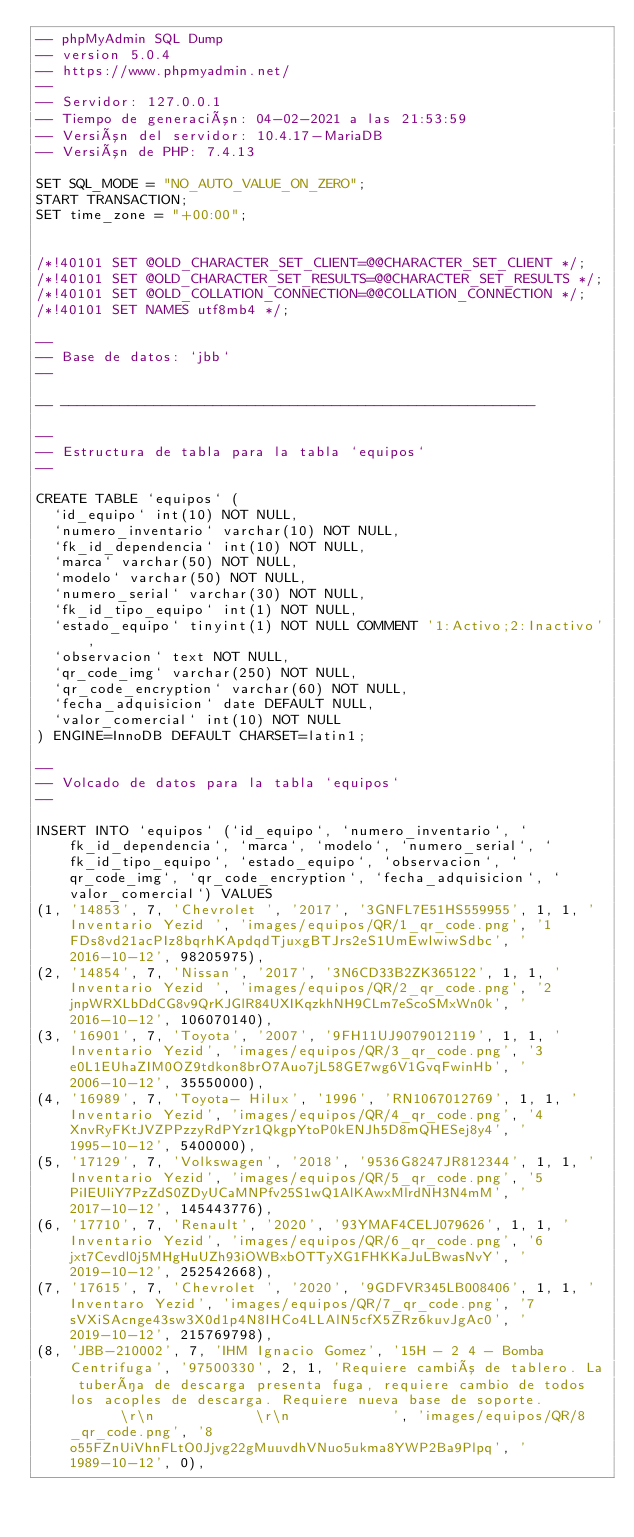<code> <loc_0><loc_0><loc_500><loc_500><_SQL_>-- phpMyAdmin SQL Dump
-- version 5.0.4
-- https://www.phpmyadmin.net/
--
-- Servidor: 127.0.0.1
-- Tiempo de generación: 04-02-2021 a las 21:53:59
-- Versión del servidor: 10.4.17-MariaDB
-- Versión de PHP: 7.4.13

SET SQL_MODE = "NO_AUTO_VALUE_ON_ZERO";
START TRANSACTION;
SET time_zone = "+00:00";


/*!40101 SET @OLD_CHARACTER_SET_CLIENT=@@CHARACTER_SET_CLIENT */;
/*!40101 SET @OLD_CHARACTER_SET_RESULTS=@@CHARACTER_SET_RESULTS */;
/*!40101 SET @OLD_COLLATION_CONNECTION=@@COLLATION_CONNECTION */;
/*!40101 SET NAMES utf8mb4 */;

--
-- Base de datos: `jbb`
--

-- --------------------------------------------------------

--
-- Estructura de tabla para la tabla `equipos`
--

CREATE TABLE `equipos` (
  `id_equipo` int(10) NOT NULL,
  `numero_inventario` varchar(10) NOT NULL,
  `fk_id_dependencia` int(10) NOT NULL,
  `marca` varchar(50) NOT NULL,
  `modelo` varchar(50) NOT NULL,
  `numero_serial` varchar(30) NOT NULL,
  `fk_id_tipo_equipo` int(1) NOT NULL,
  `estado_equipo` tinyint(1) NOT NULL COMMENT '1:Activo;2:Inactivo',
  `observacion` text NOT NULL,
  `qr_code_img` varchar(250) NOT NULL,
  `qr_code_encryption` varchar(60) NOT NULL,
  `fecha_adquisicion` date DEFAULT NULL,
  `valor_comercial` int(10) NOT NULL
) ENGINE=InnoDB DEFAULT CHARSET=latin1;

--
-- Volcado de datos para la tabla `equipos`
--

INSERT INTO `equipos` (`id_equipo`, `numero_inventario`, `fk_id_dependencia`, `marca`, `modelo`, `numero_serial`, `fk_id_tipo_equipo`, `estado_equipo`, `observacion`, `qr_code_img`, `qr_code_encryption`, `fecha_adquisicion`, `valor_comercial`) VALUES
(1, '14853', 7, 'Chevrolet ', '2017', '3GNFL7E51HS559955', 1, 1, 'Inventario Yezid ', 'images/equipos/QR/1_qr_code.png', '1FDs8vd21acPIz8bqrhKApdqdTjuxgBTJrs2eS1UmEwlwiwSdbc', '2016-10-12', 98205975),
(2, '14854', 7, 'Nissan', '2017', '3N6CD33B2ZK365122', 1, 1, 'Inventario Yezid ', 'images/equipos/QR/2_qr_code.png', '2jnpWRXLbDdCG8v9QrKJGlR84UXIKqzkhNH9CLm7eScoSMxWn0k', '2016-10-12', 106070140),
(3, '16901', 7, 'Toyota', '2007', '9FH11UJ9079012119', 1, 1, 'Inventario Yezid', 'images/equipos/QR/3_qr_code.png', '3e0L1EUhaZIM0OZ9tdkon8brO7Auo7jL58GE7wg6V1GvqFwinHb', '2006-10-12', 35550000),
(4, '16989', 7, 'Toyota- Hilux', '1996', 'RN1067012769', 1, 1, 'Inventario Yezid', 'images/equipos/QR/4_qr_code.png', '4XnvRyFKtJVZPPzzyRdPYzr1QkgpYtoP0kENJh5D8mQHESej8y4', '1995-10-12', 5400000),
(5, '17129', 7, 'Volkswagen', '2018', '9536G8247JR812344', 1, 1, 'Inventario Yezid', 'images/equipos/QR/5_qr_code.png', '5PiIEUliY7PzZdS0ZDyUCaMNPfv25S1wQ1AlKAwxMlrdNH3N4mM', '2017-10-12', 145443776),
(6, '17710', 7, 'Renault', '2020', '93YMAF4CELJ079626', 1, 1, 'Inventario Yezid', 'images/equipos/QR/6_qr_code.png', '6jxt7Cevdl0j5MHgHuUZh93iOWBxbOTTyXG1FHKKaJuLBwasNvY', '2019-10-12', 252542668),
(7, '17615', 7, 'Chevrolet ', '2020', '9GDFVR345LB008406', 1, 1, 'Inventaro Yezid', 'images/equipos/QR/7_qr_code.png', '7sVXiSAcnge43sw3X0d1p4N8IHCo4LLAlN5cfX5ZRz6kuvJgAc0', '2019-10-12', 215769798),
(8, 'JBB-210002', 7, 'IHM Ignacio Gomez', '15H - 2 4 - Bomba Centrifuga', '97500330', 2, 1, 'Requiere cambió de tablero. La tubería de descarga presenta fuga, requiere cambio de todos los acoples de descarga. Requiere nueva base de soporte.						\r\n						\r\n						', 'images/equipos/QR/8_qr_code.png', '8o55FZnUiVhnFLtO0Jjvg22gMuuvdhVNuo5ukma8YWP2Ba9Plpq', '1989-10-12', 0),</code> 